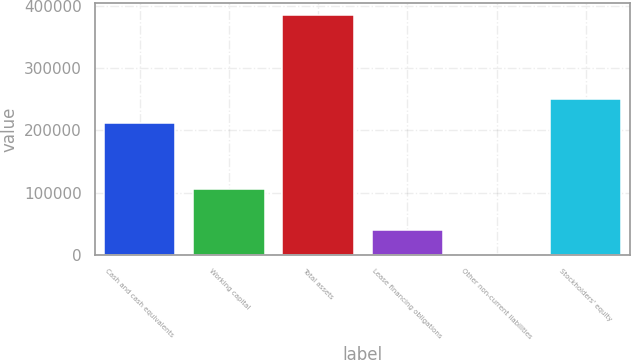Convert chart. <chart><loc_0><loc_0><loc_500><loc_500><bar_chart><fcel>Cash and cash equivalents<fcel>Working capital<fcel>Total assets<fcel>Lease financing obligations<fcel>Other non-current liabilities<fcel>Stockholders' equity<nl><fcel>212256<fcel>105776<fcel>385114<fcel>39790.3<fcel>1421<fcel>250625<nl></chart> 